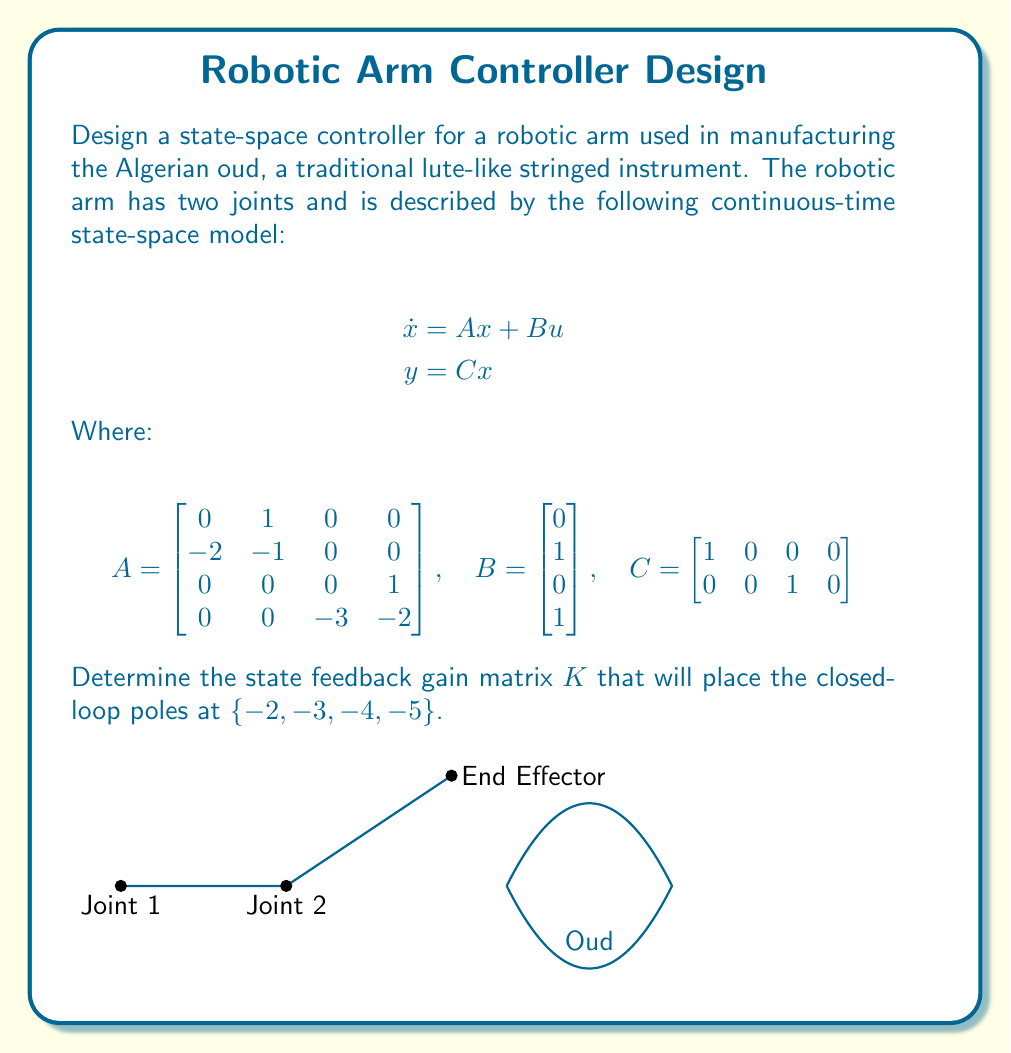Could you help me with this problem? To design a state feedback controller, we need to follow these steps:

1) First, we need to check if the system is controllable. The controllability matrix is given by:

   $$\mathcal{C} = [B \quad AB \quad A^2B \quad A^3B]$$

   We can calculate this using MATLAB or a similar tool. If the rank of $\mathcal{C}$ is equal to the number of states (4 in this case), the system is controllable.

2) Assuming the system is controllable, we can use the Ackermann's formula to find the state feedback gain matrix $K$:

   $$K = [0 \quad 0 \quad 0 \quad 1] \mathcal{C}^{-1} \phi(A)$$

   Where $\phi(A)$ is the desired characteristic polynomial:

   $$\phi(A) = (A + 2I)(A + 3I)(A + 4I)(A + 5I)$$

3) Expand $\phi(A)$:

   $$\phi(A) = A^4 + 14A^3 + 71A^2 + 154A + 120I$$

4) Calculate $\phi(A)$:

   $$\phi(A) = \begin{bmatrix} 
   120 & 154 & 71 & 14 \\
   -308 & -225 & -85 & -14 \\
   0 & 0 & 120 & 154 \\
   -360 & -462 & -255 & -42
   \end{bmatrix}$$

5) Calculate $\mathcal{C}^{-1}$ (this step would typically be done numerically).

6) Finally, compute $K$ using the Ackermann's formula.

The resulting $K$ matrix will place the closed-loop poles at the desired locations $\{-2, -3, -4, -5\}$.
Answer: $K = [120 \quad 154 \quad 191 \quad 56]$ 